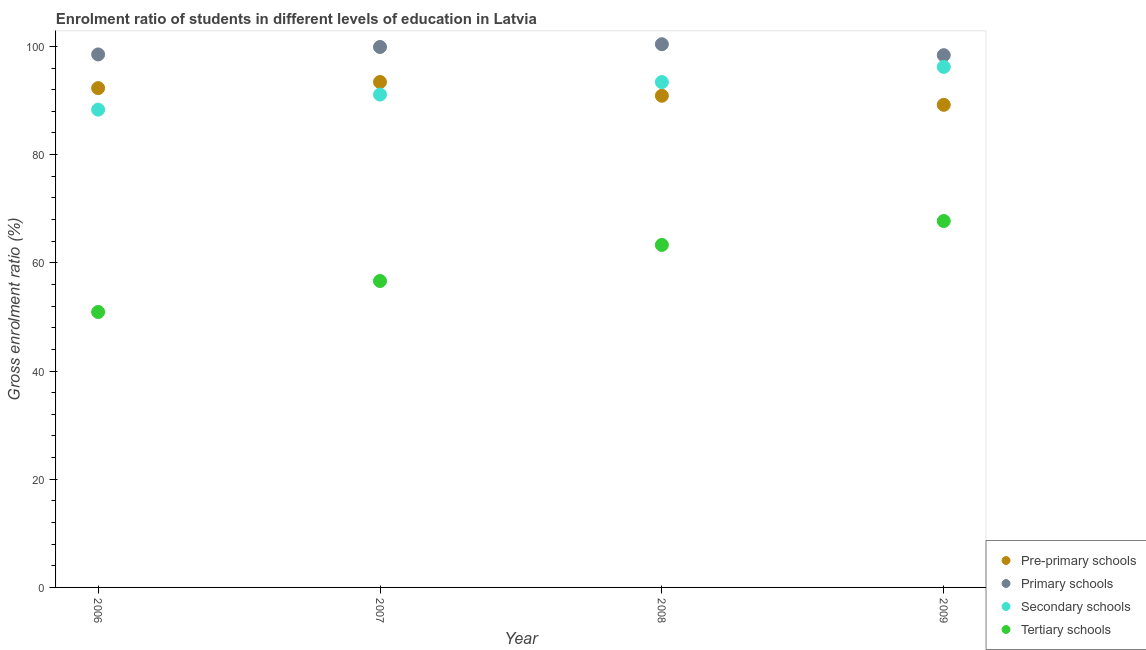What is the gross enrolment ratio in tertiary schools in 2008?
Your response must be concise. 63.3. Across all years, what is the maximum gross enrolment ratio in primary schools?
Offer a very short reply. 100.4. Across all years, what is the minimum gross enrolment ratio in primary schools?
Offer a terse response. 98.37. In which year was the gross enrolment ratio in primary schools maximum?
Provide a succinct answer. 2008. What is the total gross enrolment ratio in primary schools in the graph?
Your answer should be very brief. 397.17. What is the difference between the gross enrolment ratio in secondary schools in 2006 and that in 2008?
Provide a succinct answer. -5.09. What is the difference between the gross enrolment ratio in tertiary schools in 2007 and the gross enrolment ratio in primary schools in 2008?
Give a very brief answer. -43.76. What is the average gross enrolment ratio in secondary schools per year?
Your answer should be very brief. 92.25. In the year 2007, what is the difference between the gross enrolment ratio in secondary schools and gross enrolment ratio in pre-primary schools?
Offer a very short reply. -2.32. What is the ratio of the gross enrolment ratio in tertiary schools in 2006 to that in 2009?
Provide a succinct answer. 0.75. Is the gross enrolment ratio in primary schools in 2007 less than that in 2009?
Your answer should be compact. No. What is the difference between the highest and the second highest gross enrolment ratio in primary schools?
Ensure brevity in your answer.  0.51. What is the difference between the highest and the lowest gross enrolment ratio in pre-primary schools?
Make the answer very short. 4.21. In how many years, is the gross enrolment ratio in pre-primary schools greater than the average gross enrolment ratio in pre-primary schools taken over all years?
Keep it short and to the point. 2. Is the sum of the gross enrolment ratio in primary schools in 2008 and 2009 greater than the maximum gross enrolment ratio in secondary schools across all years?
Give a very brief answer. Yes. Is it the case that in every year, the sum of the gross enrolment ratio in pre-primary schools and gross enrolment ratio in primary schools is greater than the gross enrolment ratio in secondary schools?
Keep it short and to the point. Yes. Does the gross enrolment ratio in pre-primary schools monotonically increase over the years?
Keep it short and to the point. No. Is the gross enrolment ratio in primary schools strictly less than the gross enrolment ratio in secondary schools over the years?
Provide a succinct answer. No. What is the difference between two consecutive major ticks on the Y-axis?
Ensure brevity in your answer.  20. Are the values on the major ticks of Y-axis written in scientific E-notation?
Give a very brief answer. No. Does the graph contain any zero values?
Offer a terse response. No. What is the title of the graph?
Ensure brevity in your answer.  Enrolment ratio of students in different levels of education in Latvia. What is the label or title of the X-axis?
Ensure brevity in your answer.  Year. What is the label or title of the Y-axis?
Ensure brevity in your answer.  Gross enrolment ratio (%). What is the Gross enrolment ratio (%) of Pre-primary schools in 2006?
Your answer should be compact. 92.29. What is the Gross enrolment ratio (%) of Primary schools in 2006?
Provide a succinct answer. 98.51. What is the Gross enrolment ratio (%) of Secondary schools in 2006?
Offer a terse response. 88.31. What is the Gross enrolment ratio (%) of Tertiary schools in 2006?
Your response must be concise. 50.91. What is the Gross enrolment ratio (%) in Pre-primary schools in 2007?
Your response must be concise. 93.41. What is the Gross enrolment ratio (%) in Primary schools in 2007?
Your response must be concise. 99.89. What is the Gross enrolment ratio (%) of Secondary schools in 2007?
Your response must be concise. 91.09. What is the Gross enrolment ratio (%) of Tertiary schools in 2007?
Give a very brief answer. 56.64. What is the Gross enrolment ratio (%) in Pre-primary schools in 2008?
Your answer should be very brief. 90.87. What is the Gross enrolment ratio (%) in Primary schools in 2008?
Keep it short and to the point. 100.4. What is the Gross enrolment ratio (%) of Secondary schools in 2008?
Make the answer very short. 93.4. What is the Gross enrolment ratio (%) of Tertiary schools in 2008?
Give a very brief answer. 63.3. What is the Gross enrolment ratio (%) in Pre-primary schools in 2009?
Your answer should be very brief. 89.2. What is the Gross enrolment ratio (%) in Primary schools in 2009?
Provide a short and direct response. 98.37. What is the Gross enrolment ratio (%) in Secondary schools in 2009?
Your answer should be very brief. 96.2. What is the Gross enrolment ratio (%) of Tertiary schools in 2009?
Provide a short and direct response. 67.72. Across all years, what is the maximum Gross enrolment ratio (%) of Pre-primary schools?
Offer a terse response. 93.41. Across all years, what is the maximum Gross enrolment ratio (%) of Primary schools?
Offer a terse response. 100.4. Across all years, what is the maximum Gross enrolment ratio (%) of Secondary schools?
Give a very brief answer. 96.2. Across all years, what is the maximum Gross enrolment ratio (%) in Tertiary schools?
Provide a short and direct response. 67.72. Across all years, what is the minimum Gross enrolment ratio (%) in Pre-primary schools?
Your answer should be very brief. 89.2. Across all years, what is the minimum Gross enrolment ratio (%) in Primary schools?
Your answer should be compact. 98.37. Across all years, what is the minimum Gross enrolment ratio (%) in Secondary schools?
Your answer should be very brief. 88.31. Across all years, what is the minimum Gross enrolment ratio (%) in Tertiary schools?
Keep it short and to the point. 50.91. What is the total Gross enrolment ratio (%) of Pre-primary schools in the graph?
Give a very brief answer. 365.77. What is the total Gross enrolment ratio (%) in Primary schools in the graph?
Offer a terse response. 397.17. What is the total Gross enrolment ratio (%) of Secondary schools in the graph?
Keep it short and to the point. 369. What is the total Gross enrolment ratio (%) of Tertiary schools in the graph?
Your answer should be very brief. 238.57. What is the difference between the Gross enrolment ratio (%) in Pre-primary schools in 2006 and that in 2007?
Your answer should be very brief. -1.13. What is the difference between the Gross enrolment ratio (%) in Primary schools in 2006 and that in 2007?
Your response must be concise. -1.37. What is the difference between the Gross enrolment ratio (%) of Secondary schools in 2006 and that in 2007?
Make the answer very short. -2.78. What is the difference between the Gross enrolment ratio (%) in Tertiary schools in 2006 and that in 2007?
Offer a terse response. -5.73. What is the difference between the Gross enrolment ratio (%) in Pre-primary schools in 2006 and that in 2008?
Provide a succinct answer. 1.41. What is the difference between the Gross enrolment ratio (%) of Primary schools in 2006 and that in 2008?
Provide a short and direct response. -1.89. What is the difference between the Gross enrolment ratio (%) of Secondary schools in 2006 and that in 2008?
Provide a short and direct response. -5.09. What is the difference between the Gross enrolment ratio (%) of Tertiary schools in 2006 and that in 2008?
Offer a terse response. -12.4. What is the difference between the Gross enrolment ratio (%) in Pre-primary schools in 2006 and that in 2009?
Provide a succinct answer. 3.09. What is the difference between the Gross enrolment ratio (%) in Primary schools in 2006 and that in 2009?
Your response must be concise. 0.14. What is the difference between the Gross enrolment ratio (%) of Secondary schools in 2006 and that in 2009?
Provide a short and direct response. -7.89. What is the difference between the Gross enrolment ratio (%) of Tertiary schools in 2006 and that in 2009?
Offer a very short reply. -16.81. What is the difference between the Gross enrolment ratio (%) in Pre-primary schools in 2007 and that in 2008?
Provide a short and direct response. 2.54. What is the difference between the Gross enrolment ratio (%) in Primary schools in 2007 and that in 2008?
Your response must be concise. -0.51. What is the difference between the Gross enrolment ratio (%) of Secondary schools in 2007 and that in 2008?
Offer a terse response. -2.31. What is the difference between the Gross enrolment ratio (%) of Tertiary schools in 2007 and that in 2008?
Your answer should be compact. -6.67. What is the difference between the Gross enrolment ratio (%) of Pre-primary schools in 2007 and that in 2009?
Offer a very short reply. 4.21. What is the difference between the Gross enrolment ratio (%) in Primary schools in 2007 and that in 2009?
Give a very brief answer. 1.52. What is the difference between the Gross enrolment ratio (%) in Secondary schools in 2007 and that in 2009?
Provide a short and direct response. -5.11. What is the difference between the Gross enrolment ratio (%) of Tertiary schools in 2007 and that in 2009?
Your answer should be compact. -11.08. What is the difference between the Gross enrolment ratio (%) in Pre-primary schools in 2008 and that in 2009?
Ensure brevity in your answer.  1.67. What is the difference between the Gross enrolment ratio (%) of Primary schools in 2008 and that in 2009?
Give a very brief answer. 2.03. What is the difference between the Gross enrolment ratio (%) in Secondary schools in 2008 and that in 2009?
Keep it short and to the point. -2.8. What is the difference between the Gross enrolment ratio (%) in Tertiary schools in 2008 and that in 2009?
Make the answer very short. -4.42. What is the difference between the Gross enrolment ratio (%) of Pre-primary schools in 2006 and the Gross enrolment ratio (%) of Primary schools in 2007?
Your response must be concise. -7.6. What is the difference between the Gross enrolment ratio (%) of Pre-primary schools in 2006 and the Gross enrolment ratio (%) of Secondary schools in 2007?
Offer a very short reply. 1.19. What is the difference between the Gross enrolment ratio (%) in Pre-primary schools in 2006 and the Gross enrolment ratio (%) in Tertiary schools in 2007?
Provide a succinct answer. 35.65. What is the difference between the Gross enrolment ratio (%) in Primary schools in 2006 and the Gross enrolment ratio (%) in Secondary schools in 2007?
Offer a very short reply. 7.42. What is the difference between the Gross enrolment ratio (%) of Primary schools in 2006 and the Gross enrolment ratio (%) of Tertiary schools in 2007?
Your answer should be very brief. 41.87. What is the difference between the Gross enrolment ratio (%) of Secondary schools in 2006 and the Gross enrolment ratio (%) of Tertiary schools in 2007?
Keep it short and to the point. 31.67. What is the difference between the Gross enrolment ratio (%) in Pre-primary schools in 2006 and the Gross enrolment ratio (%) in Primary schools in 2008?
Your response must be concise. -8.11. What is the difference between the Gross enrolment ratio (%) in Pre-primary schools in 2006 and the Gross enrolment ratio (%) in Secondary schools in 2008?
Ensure brevity in your answer.  -1.11. What is the difference between the Gross enrolment ratio (%) in Pre-primary schools in 2006 and the Gross enrolment ratio (%) in Tertiary schools in 2008?
Offer a terse response. 28.98. What is the difference between the Gross enrolment ratio (%) of Primary schools in 2006 and the Gross enrolment ratio (%) of Secondary schools in 2008?
Provide a succinct answer. 5.11. What is the difference between the Gross enrolment ratio (%) in Primary schools in 2006 and the Gross enrolment ratio (%) in Tertiary schools in 2008?
Give a very brief answer. 35.21. What is the difference between the Gross enrolment ratio (%) in Secondary schools in 2006 and the Gross enrolment ratio (%) in Tertiary schools in 2008?
Your answer should be very brief. 25.01. What is the difference between the Gross enrolment ratio (%) of Pre-primary schools in 2006 and the Gross enrolment ratio (%) of Primary schools in 2009?
Your answer should be very brief. -6.09. What is the difference between the Gross enrolment ratio (%) in Pre-primary schools in 2006 and the Gross enrolment ratio (%) in Secondary schools in 2009?
Your answer should be very brief. -3.92. What is the difference between the Gross enrolment ratio (%) of Pre-primary schools in 2006 and the Gross enrolment ratio (%) of Tertiary schools in 2009?
Provide a succinct answer. 24.56. What is the difference between the Gross enrolment ratio (%) of Primary schools in 2006 and the Gross enrolment ratio (%) of Secondary schools in 2009?
Keep it short and to the point. 2.31. What is the difference between the Gross enrolment ratio (%) of Primary schools in 2006 and the Gross enrolment ratio (%) of Tertiary schools in 2009?
Keep it short and to the point. 30.79. What is the difference between the Gross enrolment ratio (%) of Secondary schools in 2006 and the Gross enrolment ratio (%) of Tertiary schools in 2009?
Ensure brevity in your answer.  20.59. What is the difference between the Gross enrolment ratio (%) of Pre-primary schools in 2007 and the Gross enrolment ratio (%) of Primary schools in 2008?
Offer a very short reply. -6.99. What is the difference between the Gross enrolment ratio (%) in Pre-primary schools in 2007 and the Gross enrolment ratio (%) in Secondary schools in 2008?
Offer a very short reply. 0.01. What is the difference between the Gross enrolment ratio (%) in Pre-primary schools in 2007 and the Gross enrolment ratio (%) in Tertiary schools in 2008?
Give a very brief answer. 30.11. What is the difference between the Gross enrolment ratio (%) in Primary schools in 2007 and the Gross enrolment ratio (%) in Secondary schools in 2008?
Make the answer very short. 6.49. What is the difference between the Gross enrolment ratio (%) of Primary schools in 2007 and the Gross enrolment ratio (%) of Tertiary schools in 2008?
Offer a very short reply. 36.58. What is the difference between the Gross enrolment ratio (%) in Secondary schools in 2007 and the Gross enrolment ratio (%) in Tertiary schools in 2008?
Give a very brief answer. 27.79. What is the difference between the Gross enrolment ratio (%) of Pre-primary schools in 2007 and the Gross enrolment ratio (%) of Primary schools in 2009?
Your answer should be very brief. -4.96. What is the difference between the Gross enrolment ratio (%) of Pre-primary schools in 2007 and the Gross enrolment ratio (%) of Secondary schools in 2009?
Provide a succinct answer. -2.79. What is the difference between the Gross enrolment ratio (%) of Pre-primary schools in 2007 and the Gross enrolment ratio (%) of Tertiary schools in 2009?
Ensure brevity in your answer.  25.69. What is the difference between the Gross enrolment ratio (%) in Primary schools in 2007 and the Gross enrolment ratio (%) in Secondary schools in 2009?
Keep it short and to the point. 3.68. What is the difference between the Gross enrolment ratio (%) in Primary schools in 2007 and the Gross enrolment ratio (%) in Tertiary schools in 2009?
Provide a short and direct response. 32.17. What is the difference between the Gross enrolment ratio (%) of Secondary schools in 2007 and the Gross enrolment ratio (%) of Tertiary schools in 2009?
Make the answer very short. 23.37. What is the difference between the Gross enrolment ratio (%) of Pre-primary schools in 2008 and the Gross enrolment ratio (%) of Primary schools in 2009?
Provide a succinct answer. -7.5. What is the difference between the Gross enrolment ratio (%) of Pre-primary schools in 2008 and the Gross enrolment ratio (%) of Secondary schools in 2009?
Provide a short and direct response. -5.33. What is the difference between the Gross enrolment ratio (%) in Pre-primary schools in 2008 and the Gross enrolment ratio (%) in Tertiary schools in 2009?
Offer a very short reply. 23.15. What is the difference between the Gross enrolment ratio (%) of Primary schools in 2008 and the Gross enrolment ratio (%) of Secondary schools in 2009?
Your answer should be very brief. 4.2. What is the difference between the Gross enrolment ratio (%) of Primary schools in 2008 and the Gross enrolment ratio (%) of Tertiary schools in 2009?
Your answer should be very brief. 32.68. What is the difference between the Gross enrolment ratio (%) in Secondary schools in 2008 and the Gross enrolment ratio (%) in Tertiary schools in 2009?
Provide a short and direct response. 25.68. What is the average Gross enrolment ratio (%) of Pre-primary schools per year?
Provide a short and direct response. 91.44. What is the average Gross enrolment ratio (%) in Primary schools per year?
Keep it short and to the point. 99.29. What is the average Gross enrolment ratio (%) of Secondary schools per year?
Your answer should be compact. 92.25. What is the average Gross enrolment ratio (%) in Tertiary schools per year?
Provide a short and direct response. 59.64. In the year 2006, what is the difference between the Gross enrolment ratio (%) of Pre-primary schools and Gross enrolment ratio (%) of Primary schools?
Provide a succinct answer. -6.23. In the year 2006, what is the difference between the Gross enrolment ratio (%) of Pre-primary schools and Gross enrolment ratio (%) of Secondary schools?
Your response must be concise. 3.97. In the year 2006, what is the difference between the Gross enrolment ratio (%) of Pre-primary schools and Gross enrolment ratio (%) of Tertiary schools?
Your response must be concise. 41.38. In the year 2006, what is the difference between the Gross enrolment ratio (%) of Primary schools and Gross enrolment ratio (%) of Secondary schools?
Make the answer very short. 10.2. In the year 2006, what is the difference between the Gross enrolment ratio (%) in Primary schools and Gross enrolment ratio (%) in Tertiary schools?
Provide a short and direct response. 47.6. In the year 2006, what is the difference between the Gross enrolment ratio (%) of Secondary schools and Gross enrolment ratio (%) of Tertiary schools?
Provide a short and direct response. 37.4. In the year 2007, what is the difference between the Gross enrolment ratio (%) of Pre-primary schools and Gross enrolment ratio (%) of Primary schools?
Provide a succinct answer. -6.47. In the year 2007, what is the difference between the Gross enrolment ratio (%) in Pre-primary schools and Gross enrolment ratio (%) in Secondary schools?
Ensure brevity in your answer.  2.32. In the year 2007, what is the difference between the Gross enrolment ratio (%) in Pre-primary schools and Gross enrolment ratio (%) in Tertiary schools?
Offer a terse response. 36.78. In the year 2007, what is the difference between the Gross enrolment ratio (%) in Primary schools and Gross enrolment ratio (%) in Secondary schools?
Ensure brevity in your answer.  8.79. In the year 2007, what is the difference between the Gross enrolment ratio (%) of Primary schools and Gross enrolment ratio (%) of Tertiary schools?
Your response must be concise. 43.25. In the year 2007, what is the difference between the Gross enrolment ratio (%) of Secondary schools and Gross enrolment ratio (%) of Tertiary schools?
Offer a very short reply. 34.45. In the year 2008, what is the difference between the Gross enrolment ratio (%) in Pre-primary schools and Gross enrolment ratio (%) in Primary schools?
Your response must be concise. -9.53. In the year 2008, what is the difference between the Gross enrolment ratio (%) in Pre-primary schools and Gross enrolment ratio (%) in Secondary schools?
Your response must be concise. -2.53. In the year 2008, what is the difference between the Gross enrolment ratio (%) in Pre-primary schools and Gross enrolment ratio (%) in Tertiary schools?
Your answer should be compact. 27.57. In the year 2008, what is the difference between the Gross enrolment ratio (%) in Primary schools and Gross enrolment ratio (%) in Secondary schools?
Your answer should be very brief. 7. In the year 2008, what is the difference between the Gross enrolment ratio (%) in Primary schools and Gross enrolment ratio (%) in Tertiary schools?
Offer a terse response. 37.09. In the year 2008, what is the difference between the Gross enrolment ratio (%) of Secondary schools and Gross enrolment ratio (%) of Tertiary schools?
Give a very brief answer. 30.09. In the year 2009, what is the difference between the Gross enrolment ratio (%) of Pre-primary schools and Gross enrolment ratio (%) of Primary schools?
Your response must be concise. -9.17. In the year 2009, what is the difference between the Gross enrolment ratio (%) in Pre-primary schools and Gross enrolment ratio (%) in Secondary schools?
Give a very brief answer. -7. In the year 2009, what is the difference between the Gross enrolment ratio (%) of Pre-primary schools and Gross enrolment ratio (%) of Tertiary schools?
Provide a short and direct response. 21.48. In the year 2009, what is the difference between the Gross enrolment ratio (%) of Primary schools and Gross enrolment ratio (%) of Secondary schools?
Give a very brief answer. 2.17. In the year 2009, what is the difference between the Gross enrolment ratio (%) of Primary schools and Gross enrolment ratio (%) of Tertiary schools?
Your response must be concise. 30.65. In the year 2009, what is the difference between the Gross enrolment ratio (%) in Secondary schools and Gross enrolment ratio (%) in Tertiary schools?
Give a very brief answer. 28.48. What is the ratio of the Gross enrolment ratio (%) in Pre-primary schools in 2006 to that in 2007?
Offer a terse response. 0.99. What is the ratio of the Gross enrolment ratio (%) in Primary schools in 2006 to that in 2007?
Provide a succinct answer. 0.99. What is the ratio of the Gross enrolment ratio (%) in Secondary schools in 2006 to that in 2007?
Ensure brevity in your answer.  0.97. What is the ratio of the Gross enrolment ratio (%) of Tertiary schools in 2006 to that in 2007?
Keep it short and to the point. 0.9. What is the ratio of the Gross enrolment ratio (%) of Pre-primary schools in 2006 to that in 2008?
Make the answer very short. 1.02. What is the ratio of the Gross enrolment ratio (%) in Primary schools in 2006 to that in 2008?
Your answer should be very brief. 0.98. What is the ratio of the Gross enrolment ratio (%) in Secondary schools in 2006 to that in 2008?
Offer a terse response. 0.95. What is the ratio of the Gross enrolment ratio (%) of Tertiary schools in 2006 to that in 2008?
Give a very brief answer. 0.8. What is the ratio of the Gross enrolment ratio (%) in Pre-primary schools in 2006 to that in 2009?
Your answer should be very brief. 1.03. What is the ratio of the Gross enrolment ratio (%) of Secondary schools in 2006 to that in 2009?
Your response must be concise. 0.92. What is the ratio of the Gross enrolment ratio (%) of Tertiary schools in 2006 to that in 2009?
Offer a very short reply. 0.75. What is the ratio of the Gross enrolment ratio (%) of Pre-primary schools in 2007 to that in 2008?
Ensure brevity in your answer.  1.03. What is the ratio of the Gross enrolment ratio (%) of Secondary schools in 2007 to that in 2008?
Offer a terse response. 0.98. What is the ratio of the Gross enrolment ratio (%) in Tertiary schools in 2007 to that in 2008?
Offer a very short reply. 0.89. What is the ratio of the Gross enrolment ratio (%) in Pre-primary schools in 2007 to that in 2009?
Provide a succinct answer. 1.05. What is the ratio of the Gross enrolment ratio (%) in Primary schools in 2007 to that in 2009?
Your answer should be compact. 1.02. What is the ratio of the Gross enrolment ratio (%) in Secondary schools in 2007 to that in 2009?
Offer a very short reply. 0.95. What is the ratio of the Gross enrolment ratio (%) of Tertiary schools in 2007 to that in 2009?
Offer a very short reply. 0.84. What is the ratio of the Gross enrolment ratio (%) in Pre-primary schools in 2008 to that in 2009?
Give a very brief answer. 1.02. What is the ratio of the Gross enrolment ratio (%) of Primary schools in 2008 to that in 2009?
Provide a succinct answer. 1.02. What is the ratio of the Gross enrolment ratio (%) of Secondary schools in 2008 to that in 2009?
Provide a short and direct response. 0.97. What is the ratio of the Gross enrolment ratio (%) in Tertiary schools in 2008 to that in 2009?
Your answer should be very brief. 0.93. What is the difference between the highest and the second highest Gross enrolment ratio (%) in Pre-primary schools?
Offer a very short reply. 1.13. What is the difference between the highest and the second highest Gross enrolment ratio (%) of Primary schools?
Provide a succinct answer. 0.51. What is the difference between the highest and the second highest Gross enrolment ratio (%) of Secondary schools?
Make the answer very short. 2.8. What is the difference between the highest and the second highest Gross enrolment ratio (%) of Tertiary schools?
Give a very brief answer. 4.42. What is the difference between the highest and the lowest Gross enrolment ratio (%) of Pre-primary schools?
Keep it short and to the point. 4.21. What is the difference between the highest and the lowest Gross enrolment ratio (%) of Primary schools?
Your response must be concise. 2.03. What is the difference between the highest and the lowest Gross enrolment ratio (%) of Secondary schools?
Offer a terse response. 7.89. What is the difference between the highest and the lowest Gross enrolment ratio (%) in Tertiary schools?
Give a very brief answer. 16.81. 